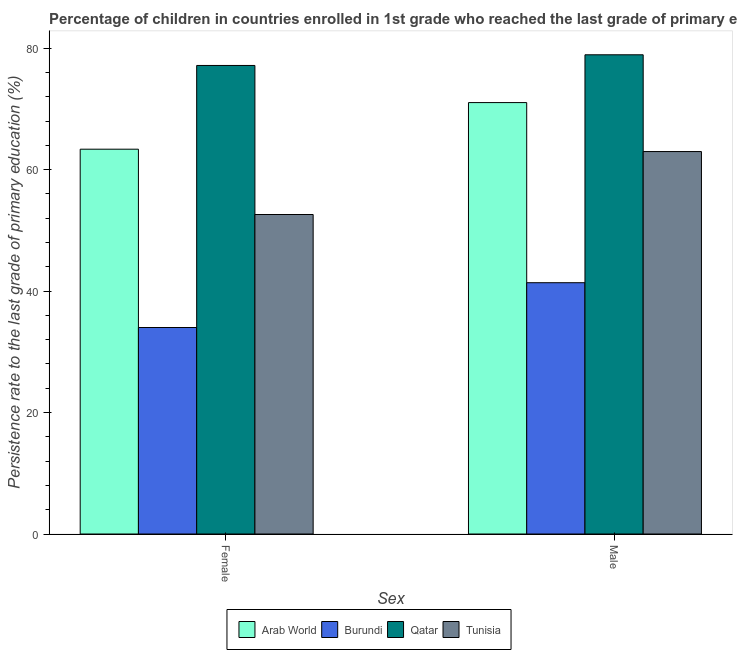How many different coloured bars are there?
Provide a short and direct response. 4. How many groups of bars are there?
Your answer should be very brief. 2. How many bars are there on the 2nd tick from the left?
Give a very brief answer. 4. How many bars are there on the 2nd tick from the right?
Keep it short and to the point. 4. What is the persistence rate of female students in Burundi?
Keep it short and to the point. 34. Across all countries, what is the maximum persistence rate of male students?
Your answer should be very brief. 78.91. Across all countries, what is the minimum persistence rate of female students?
Your answer should be compact. 34. In which country was the persistence rate of female students maximum?
Ensure brevity in your answer.  Qatar. In which country was the persistence rate of male students minimum?
Offer a terse response. Burundi. What is the total persistence rate of female students in the graph?
Offer a terse response. 227.13. What is the difference between the persistence rate of female students in Tunisia and that in Arab World?
Your answer should be compact. -10.76. What is the difference between the persistence rate of female students in Tunisia and the persistence rate of male students in Qatar?
Make the answer very short. -26.3. What is the average persistence rate of male students per country?
Your answer should be compact. 63.58. What is the difference between the persistence rate of female students and persistence rate of male students in Tunisia?
Offer a terse response. -10.37. What is the ratio of the persistence rate of male students in Burundi to that in Tunisia?
Your response must be concise. 0.66. In how many countries, is the persistence rate of male students greater than the average persistence rate of male students taken over all countries?
Keep it short and to the point. 2. What does the 4th bar from the left in Female represents?
Offer a very short reply. Tunisia. What does the 3rd bar from the right in Female represents?
Keep it short and to the point. Burundi. How many bars are there?
Offer a terse response. 8. How many countries are there in the graph?
Keep it short and to the point. 4. Does the graph contain grids?
Give a very brief answer. No. Where does the legend appear in the graph?
Offer a terse response. Bottom center. How many legend labels are there?
Your answer should be compact. 4. How are the legend labels stacked?
Your answer should be very brief. Horizontal. What is the title of the graph?
Provide a succinct answer. Percentage of children in countries enrolled in 1st grade who reached the last grade of primary education. What is the label or title of the X-axis?
Keep it short and to the point. Sex. What is the label or title of the Y-axis?
Give a very brief answer. Persistence rate to the last grade of primary education (%). What is the Persistence rate to the last grade of primary education (%) of Arab World in Female?
Give a very brief answer. 63.37. What is the Persistence rate to the last grade of primary education (%) in Burundi in Female?
Make the answer very short. 34. What is the Persistence rate to the last grade of primary education (%) in Qatar in Female?
Your response must be concise. 77.15. What is the Persistence rate to the last grade of primary education (%) in Tunisia in Female?
Offer a very short reply. 52.61. What is the Persistence rate to the last grade of primary education (%) of Arab World in Male?
Provide a succinct answer. 71.04. What is the Persistence rate to the last grade of primary education (%) in Burundi in Male?
Keep it short and to the point. 41.38. What is the Persistence rate to the last grade of primary education (%) in Qatar in Male?
Provide a succinct answer. 78.91. What is the Persistence rate to the last grade of primary education (%) in Tunisia in Male?
Provide a succinct answer. 62.98. Across all Sex, what is the maximum Persistence rate to the last grade of primary education (%) in Arab World?
Keep it short and to the point. 71.04. Across all Sex, what is the maximum Persistence rate to the last grade of primary education (%) in Burundi?
Provide a succinct answer. 41.38. Across all Sex, what is the maximum Persistence rate to the last grade of primary education (%) in Qatar?
Offer a terse response. 78.91. Across all Sex, what is the maximum Persistence rate to the last grade of primary education (%) of Tunisia?
Give a very brief answer. 62.98. Across all Sex, what is the minimum Persistence rate to the last grade of primary education (%) of Arab World?
Your response must be concise. 63.37. Across all Sex, what is the minimum Persistence rate to the last grade of primary education (%) in Burundi?
Give a very brief answer. 34. Across all Sex, what is the minimum Persistence rate to the last grade of primary education (%) of Qatar?
Your answer should be very brief. 77.15. Across all Sex, what is the minimum Persistence rate to the last grade of primary education (%) in Tunisia?
Give a very brief answer. 52.61. What is the total Persistence rate to the last grade of primary education (%) in Arab World in the graph?
Offer a very short reply. 134.4. What is the total Persistence rate to the last grade of primary education (%) of Burundi in the graph?
Offer a very short reply. 75.38. What is the total Persistence rate to the last grade of primary education (%) of Qatar in the graph?
Make the answer very short. 156.07. What is the total Persistence rate to the last grade of primary education (%) in Tunisia in the graph?
Provide a short and direct response. 115.59. What is the difference between the Persistence rate to the last grade of primary education (%) in Arab World in Female and that in Male?
Provide a succinct answer. -7.67. What is the difference between the Persistence rate to the last grade of primary education (%) of Burundi in Female and that in Male?
Make the answer very short. -7.38. What is the difference between the Persistence rate to the last grade of primary education (%) in Qatar in Female and that in Male?
Ensure brevity in your answer.  -1.76. What is the difference between the Persistence rate to the last grade of primary education (%) of Tunisia in Female and that in Male?
Your answer should be very brief. -10.37. What is the difference between the Persistence rate to the last grade of primary education (%) in Arab World in Female and the Persistence rate to the last grade of primary education (%) in Burundi in Male?
Keep it short and to the point. 21.99. What is the difference between the Persistence rate to the last grade of primary education (%) in Arab World in Female and the Persistence rate to the last grade of primary education (%) in Qatar in Male?
Provide a succinct answer. -15.55. What is the difference between the Persistence rate to the last grade of primary education (%) of Arab World in Female and the Persistence rate to the last grade of primary education (%) of Tunisia in Male?
Your answer should be very brief. 0.39. What is the difference between the Persistence rate to the last grade of primary education (%) in Burundi in Female and the Persistence rate to the last grade of primary education (%) in Qatar in Male?
Make the answer very short. -44.91. What is the difference between the Persistence rate to the last grade of primary education (%) of Burundi in Female and the Persistence rate to the last grade of primary education (%) of Tunisia in Male?
Your response must be concise. -28.97. What is the difference between the Persistence rate to the last grade of primary education (%) of Qatar in Female and the Persistence rate to the last grade of primary education (%) of Tunisia in Male?
Offer a terse response. 14.18. What is the average Persistence rate to the last grade of primary education (%) in Arab World per Sex?
Make the answer very short. 67.2. What is the average Persistence rate to the last grade of primary education (%) of Burundi per Sex?
Keep it short and to the point. 37.69. What is the average Persistence rate to the last grade of primary education (%) of Qatar per Sex?
Make the answer very short. 78.03. What is the average Persistence rate to the last grade of primary education (%) of Tunisia per Sex?
Your response must be concise. 57.79. What is the difference between the Persistence rate to the last grade of primary education (%) of Arab World and Persistence rate to the last grade of primary education (%) of Burundi in Female?
Provide a short and direct response. 29.36. What is the difference between the Persistence rate to the last grade of primary education (%) in Arab World and Persistence rate to the last grade of primary education (%) in Qatar in Female?
Your answer should be compact. -13.79. What is the difference between the Persistence rate to the last grade of primary education (%) in Arab World and Persistence rate to the last grade of primary education (%) in Tunisia in Female?
Give a very brief answer. 10.76. What is the difference between the Persistence rate to the last grade of primary education (%) in Burundi and Persistence rate to the last grade of primary education (%) in Qatar in Female?
Your response must be concise. -43.15. What is the difference between the Persistence rate to the last grade of primary education (%) of Burundi and Persistence rate to the last grade of primary education (%) of Tunisia in Female?
Make the answer very short. -18.61. What is the difference between the Persistence rate to the last grade of primary education (%) of Qatar and Persistence rate to the last grade of primary education (%) of Tunisia in Female?
Ensure brevity in your answer.  24.55. What is the difference between the Persistence rate to the last grade of primary education (%) of Arab World and Persistence rate to the last grade of primary education (%) of Burundi in Male?
Make the answer very short. 29.66. What is the difference between the Persistence rate to the last grade of primary education (%) of Arab World and Persistence rate to the last grade of primary education (%) of Qatar in Male?
Your answer should be compact. -7.87. What is the difference between the Persistence rate to the last grade of primary education (%) in Arab World and Persistence rate to the last grade of primary education (%) in Tunisia in Male?
Keep it short and to the point. 8.06. What is the difference between the Persistence rate to the last grade of primary education (%) in Burundi and Persistence rate to the last grade of primary education (%) in Qatar in Male?
Your response must be concise. -37.53. What is the difference between the Persistence rate to the last grade of primary education (%) in Burundi and Persistence rate to the last grade of primary education (%) in Tunisia in Male?
Give a very brief answer. -21.6. What is the difference between the Persistence rate to the last grade of primary education (%) in Qatar and Persistence rate to the last grade of primary education (%) in Tunisia in Male?
Offer a terse response. 15.93. What is the ratio of the Persistence rate to the last grade of primary education (%) in Arab World in Female to that in Male?
Keep it short and to the point. 0.89. What is the ratio of the Persistence rate to the last grade of primary education (%) of Burundi in Female to that in Male?
Offer a very short reply. 0.82. What is the ratio of the Persistence rate to the last grade of primary education (%) of Qatar in Female to that in Male?
Ensure brevity in your answer.  0.98. What is the ratio of the Persistence rate to the last grade of primary education (%) in Tunisia in Female to that in Male?
Offer a terse response. 0.84. What is the difference between the highest and the second highest Persistence rate to the last grade of primary education (%) of Arab World?
Provide a short and direct response. 7.67. What is the difference between the highest and the second highest Persistence rate to the last grade of primary education (%) in Burundi?
Make the answer very short. 7.38. What is the difference between the highest and the second highest Persistence rate to the last grade of primary education (%) in Qatar?
Your answer should be very brief. 1.76. What is the difference between the highest and the second highest Persistence rate to the last grade of primary education (%) in Tunisia?
Provide a succinct answer. 10.37. What is the difference between the highest and the lowest Persistence rate to the last grade of primary education (%) in Arab World?
Provide a short and direct response. 7.67. What is the difference between the highest and the lowest Persistence rate to the last grade of primary education (%) in Burundi?
Your response must be concise. 7.38. What is the difference between the highest and the lowest Persistence rate to the last grade of primary education (%) of Qatar?
Your answer should be very brief. 1.76. What is the difference between the highest and the lowest Persistence rate to the last grade of primary education (%) of Tunisia?
Make the answer very short. 10.37. 